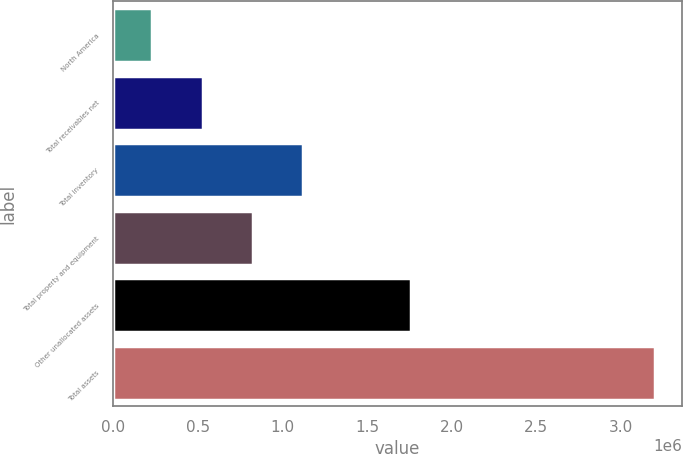Convert chart to OTSL. <chart><loc_0><loc_0><loc_500><loc_500><bar_chart><fcel>North America<fcel>Total receivables net<fcel>Total inventory<fcel>Total property and equipment<fcel>Other unallocated assets<fcel>Total assets<nl><fcel>230871<fcel>527754<fcel>1.12152e+06<fcel>824638<fcel>1.757e+06<fcel>3.1997e+06<nl></chart> 